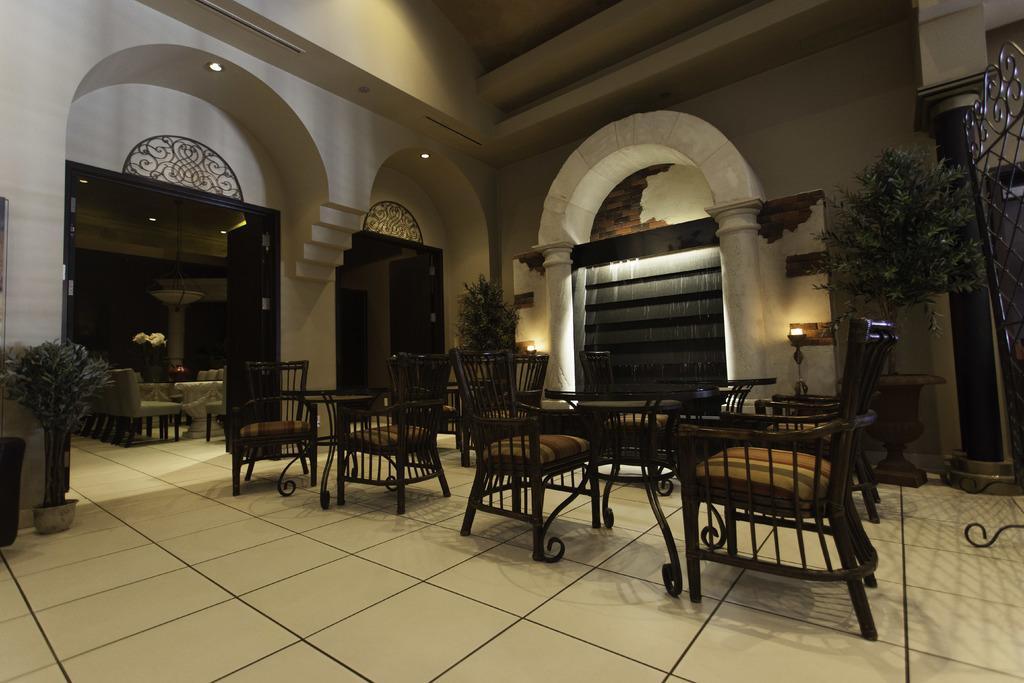Can you describe this image briefly? In the image I can see a place where we have some chairs around the tables and also I can see some light s to the roof. 